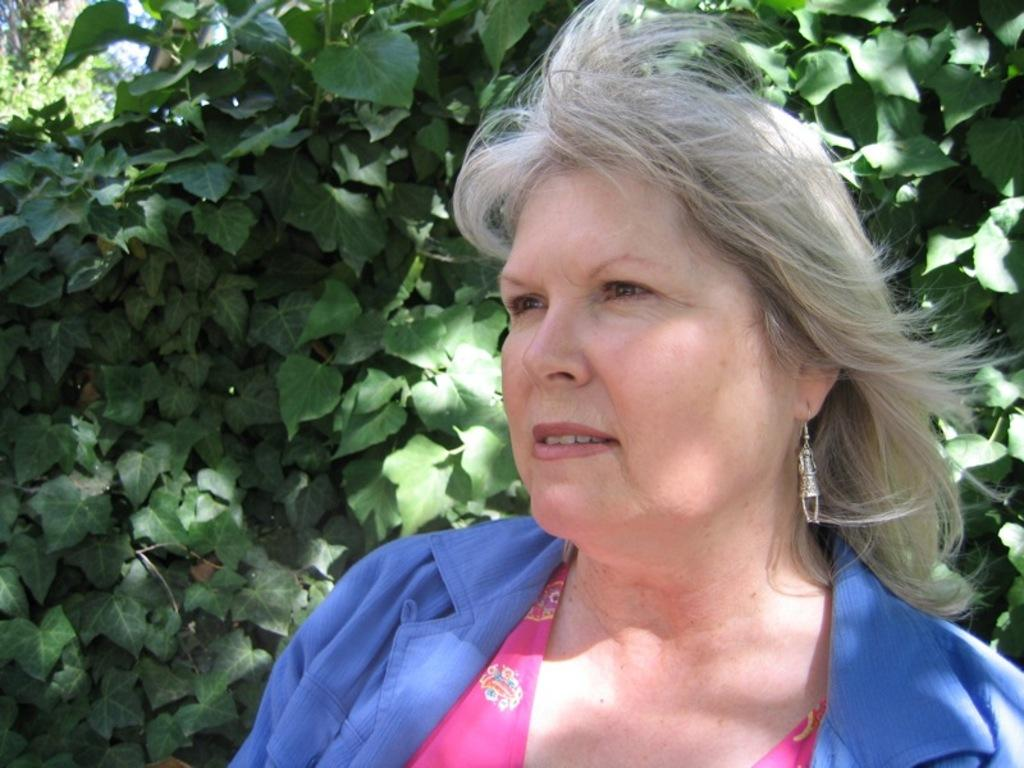What is the main subject of the image? The main subject of the image is a woman standing. What can be seen in the background of the image? There are plants in the background of the image. What type of creature is present at the meeting in the image? There is no meeting or creature present in the image; it features a woman standing in front of plants. 